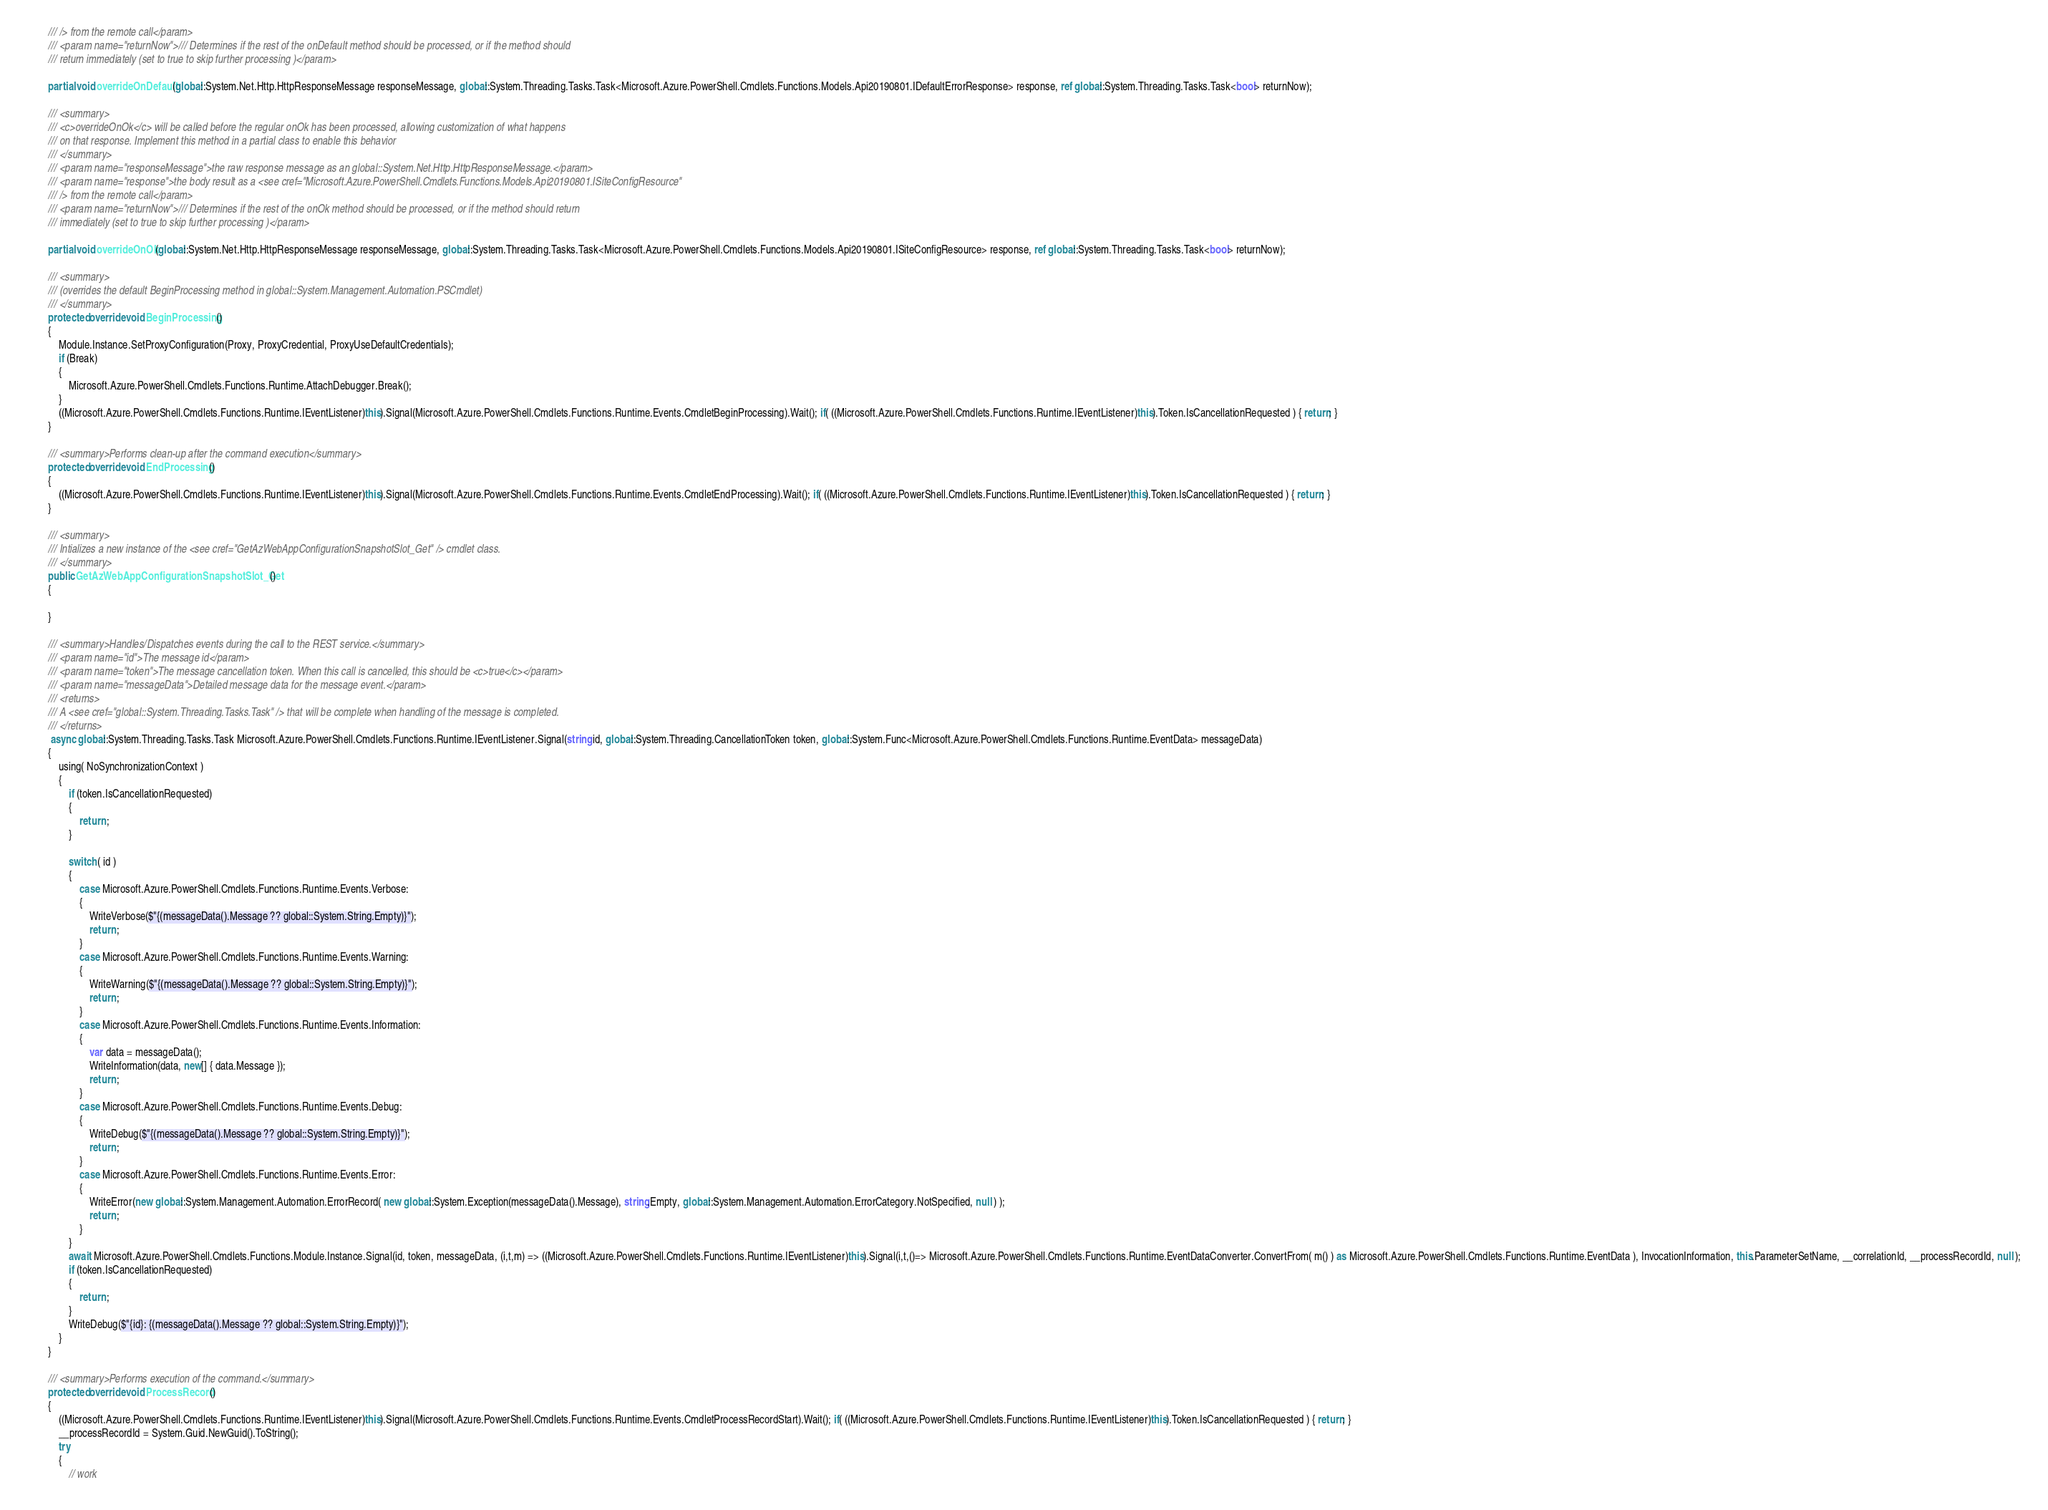Convert code to text. <code><loc_0><loc_0><loc_500><loc_500><_C#_>        /// /> from the remote call</param>
        /// <param name="returnNow">/// Determines if the rest of the onDefault method should be processed, or if the method should
        /// return immediately (set to true to skip further processing )</param>

        partial void overrideOnDefault(global::System.Net.Http.HttpResponseMessage responseMessage, global::System.Threading.Tasks.Task<Microsoft.Azure.PowerShell.Cmdlets.Functions.Models.Api20190801.IDefaultErrorResponse> response, ref global::System.Threading.Tasks.Task<bool> returnNow);

        /// <summary>
        /// <c>overrideOnOk</c> will be called before the regular onOk has been processed, allowing customization of what happens
        /// on that response. Implement this method in a partial class to enable this behavior
        /// </summary>
        /// <param name="responseMessage">the raw response message as an global::System.Net.Http.HttpResponseMessage.</param>
        /// <param name="response">the body result as a <see cref="Microsoft.Azure.PowerShell.Cmdlets.Functions.Models.Api20190801.ISiteConfigResource"
        /// /> from the remote call</param>
        /// <param name="returnNow">/// Determines if the rest of the onOk method should be processed, or if the method should return
        /// immediately (set to true to skip further processing )</param>

        partial void overrideOnOk(global::System.Net.Http.HttpResponseMessage responseMessage, global::System.Threading.Tasks.Task<Microsoft.Azure.PowerShell.Cmdlets.Functions.Models.Api20190801.ISiteConfigResource> response, ref global::System.Threading.Tasks.Task<bool> returnNow);

        /// <summary>
        /// (overrides the default BeginProcessing method in global::System.Management.Automation.PSCmdlet)
        /// </summary>
        protected override void BeginProcessing()
        {
            Module.Instance.SetProxyConfiguration(Proxy, ProxyCredential, ProxyUseDefaultCredentials);
            if (Break)
            {
                Microsoft.Azure.PowerShell.Cmdlets.Functions.Runtime.AttachDebugger.Break();
            }
            ((Microsoft.Azure.PowerShell.Cmdlets.Functions.Runtime.IEventListener)this).Signal(Microsoft.Azure.PowerShell.Cmdlets.Functions.Runtime.Events.CmdletBeginProcessing).Wait(); if( ((Microsoft.Azure.PowerShell.Cmdlets.Functions.Runtime.IEventListener)this).Token.IsCancellationRequested ) { return; }
        }

        /// <summary>Performs clean-up after the command execution</summary>
        protected override void EndProcessing()
        {
            ((Microsoft.Azure.PowerShell.Cmdlets.Functions.Runtime.IEventListener)this).Signal(Microsoft.Azure.PowerShell.Cmdlets.Functions.Runtime.Events.CmdletEndProcessing).Wait(); if( ((Microsoft.Azure.PowerShell.Cmdlets.Functions.Runtime.IEventListener)this).Token.IsCancellationRequested ) { return; }
        }

        /// <summary>
        /// Intializes a new instance of the <see cref="GetAzWebAppConfigurationSnapshotSlot_Get" /> cmdlet class.
        /// </summary>
        public GetAzWebAppConfigurationSnapshotSlot_Get()
        {

        }

        /// <summary>Handles/Dispatches events during the call to the REST service.</summary>
        /// <param name="id">The message id</param>
        /// <param name="token">The message cancellation token. When this call is cancelled, this should be <c>true</c></param>
        /// <param name="messageData">Detailed message data for the message event.</param>
        /// <returns>
        /// A <see cref="global::System.Threading.Tasks.Task" /> that will be complete when handling of the message is completed.
        /// </returns>
         async global::System.Threading.Tasks.Task Microsoft.Azure.PowerShell.Cmdlets.Functions.Runtime.IEventListener.Signal(string id, global::System.Threading.CancellationToken token, global::System.Func<Microsoft.Azure.PowerShell.Cmdlets.Functions.Runtime.EventData> messageData)
        {
            using( NoSynchronizationContext )
            {
                if (token.IsCancellationRequested)
                {
                    return ;
                }

                switch ( id )
                {
                    case Microsoft.Azure.PowerShell.Cmdlets.Functions.Runtime.Events.Verbose:
                    {
                        WriteVerbose($"{(messageData().Message ?? global::System.String.Empty)}");
                        return ;
                    }
                    case Microsoft.Azure.PowerShell.Cmdlets.Functions.Runtime.Events.Warning:
                    {
                        WriteWarning($"{(messageData().Message ?? global::System.String.Empty)}");
                        return ;
                    }
                    case Microsoft.Azure.PowerShell.Cmdlets.Functions.Runtime.Events.Information:
                    {
                        var data = messageData();
                        WriteInformation(data, new[] { data.Message });
                        return ;
                    }
                    case Microsoft.Azure.PowerShell.Cmdlets.Functions.Runtime.Events.Debug:
                    {
                        WriteDebug($"{(messageData().Message ?? global::System.String.Empty)}");
                        return ;
                    }
                    case Microsoft.Azure.PowerShell.Cmdlets.Functions.Runtime.Events.Error:
                    {
                        WriteError(new global::System.Management.Automation.ErrorRecord( new global::System.Exception(messageData().Message), string.Empty, global::System.Management.Automation.ErrorCategory.NotSpecified, null ) );
                        return ;
                    }
                }
                await Microsoft.Azure.PowerShell.Cmdlets.Functions.Module.Instance.Signal(id, token, messageData, (i,t,m) => ((Microsoft.Azure.PowerShell.Cmdlets.Functions.Runtime.IEventListener)this).Signal(i,t,()=> Microsoft.Azure.PowerShell.Cmdlets.Functions.Runtime.EventDataConverter.ConvertFrom( m() ) as Microsoft.Azure.PowerShell.Cmdlets.Functions.Runtime.EventData ), InvocationInformation, this.ParameterSetName, __correlationId, __processRecordId, null );
                if (token.IsCancellationRequested)
                {
                    return ;
                }
                WriteDebug($"{id}: {(messageData().Message ?? global::System.String.Empty)}");
            }
        }

        /// <summary>Performs execution of the command.</summary>
        protected override void ProcessRecord()
        {
            ((Microsoft.Azure.PowerShell.Cmdlets.Functions.Runtime.IEventListener)this).Signal(Microsoft.Azure.PowerShell.Cmdlets.Functions.Runtime.Events.CmdletProcessRecordStart).Wait(); if( ((Microsoft.Azure.PowerShell.Cmdlets.Functions.Runtime.IEventListener)this).Token.IsCancellationRequested ) { return; }
            __processRecordId = System.Guid.NewGuid().ToString();
            try
            {
                // work</code> 